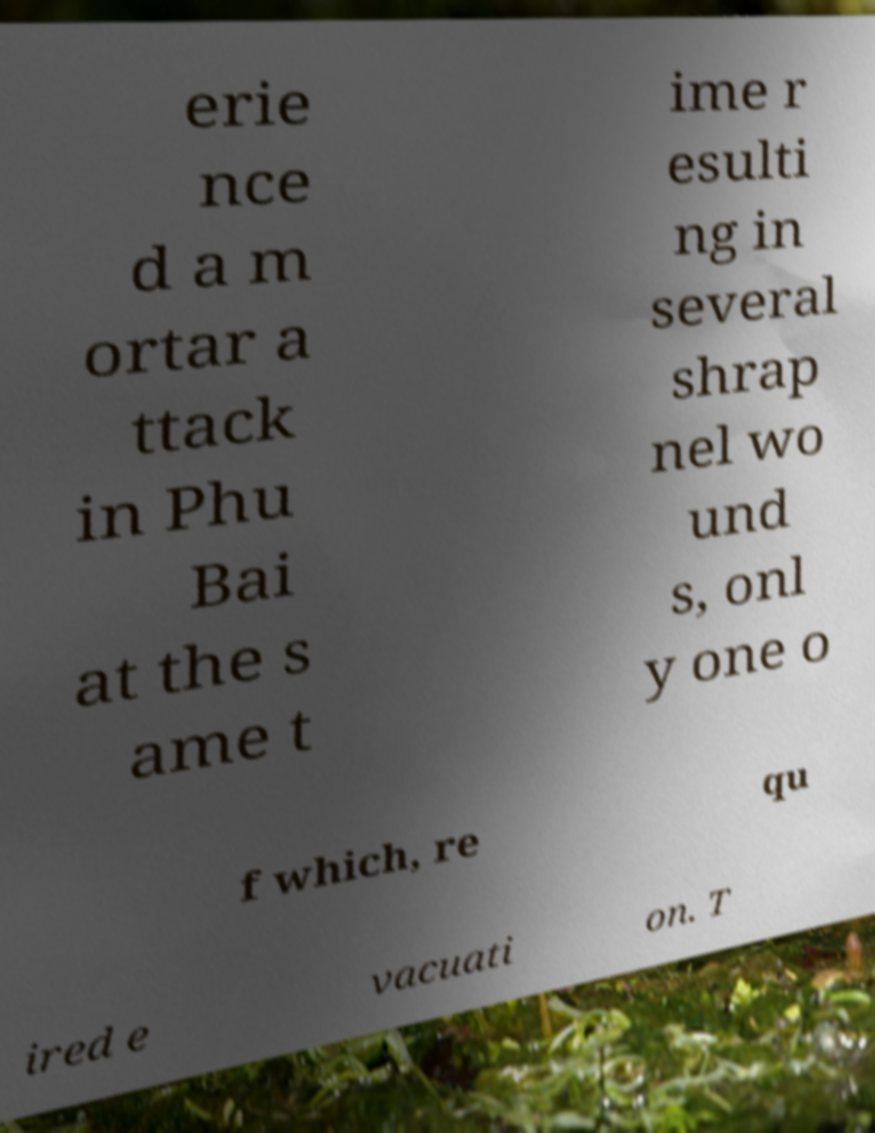I need the written content from this picture converted into text. Can you do that? erie nce d a m ortar a ttack in Phu Bai at the s ame t ime r esulti ng in several shrap nel wo und s, onl y one o f which, re qu ired e vacuati on. T 